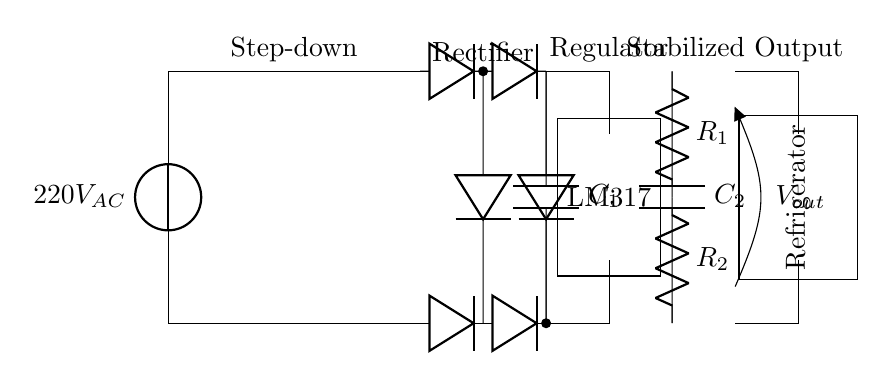What type of voltage does this circuit provide? This circuit provides a stabilized Direct Current (DC) output, as it includes components like a rectifier and a voltage regulator that convert AC to DC and stabilize the voltage.
Answer: DC What is the function of the transformer in this circuit? The transformer is used to step down the voltage from 220 volts AC to a lower voltage before it is rectified and regulated. This reduces the voltage to a safer level for the refrigerator.
Answer: Step-down How many diodes are used in the rectifier bridge? There are four diodes used in the rectifier bridge, as shown at the rectifier section where the circuit connects to the AC input.
Answer: Four What is the purpose of the smoothing capacitor in the circuit? The smoothing capacitor helps to reduce voltage ripples after the rectification process, providing a smoother DC output for the voltage regulator to work effectively.
Answer: Reduce ripples What is the output voltage provided by the regulator? The output voltage is specifically set by the resistors connected to the voltage regulator, LM317, which adjusts the output voltage based on the resistor values.
Answer: Regulated value Which component stabilizes the output voltage for the refrigerator? The LM317 voltage regulator stabilizes the output voltage by adjusting its output based on input voltage variations and load changes, ensuring a consistent output.
Answer: LM317 